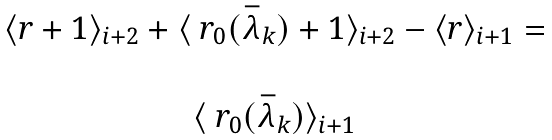Convert formula to latex. <formula><loc_0><loc_0><loc_500><loc_500>\begin{matrix} \\ \langle r + 1 \rangle _ { i + 2 } + \langle \ r _ { 0 } ( \bar { \lambda } _ { k } ) + 1 \rangle _ { i + 2 } - \langle r \rangle _ { i + 1 } = \\ \\ \langle \ r _ { 0 } ( \bar { \lambda } _ { k } ) \rangle _ { i + 1 } \\ \ \end{matrix}</formula> 